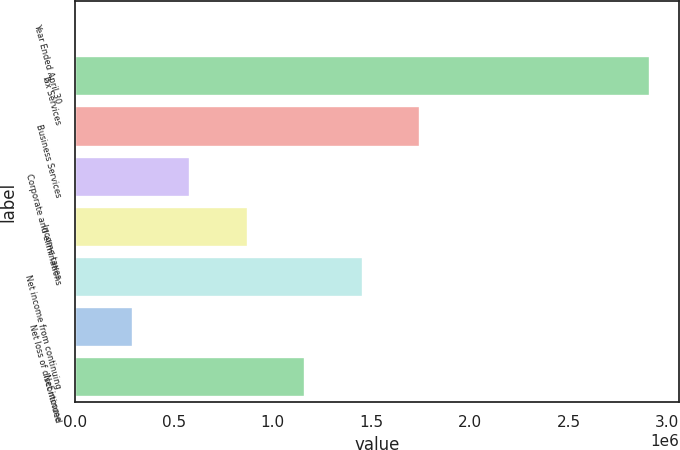Convert chart to OTSL. <chart><loc_0><loc_0><loc_500><loc_500><bar_chart><fcel>Year Ended April 30<fcel>Tax Services<fcel>Business Services<fcel>Corporate and eliminations<fcel>Income taxes<fcel>Net income from continuing<fcel>Net loss of discontinued<fcel>Net income<nl><fcel>2011<fcel>2.91236e+06<fcel>1.74822e+06<fcel>584081<fcel>875116<fcel>1.45719e+06<fcel>293046<fcel>1.16615e+06<nl></chart> 